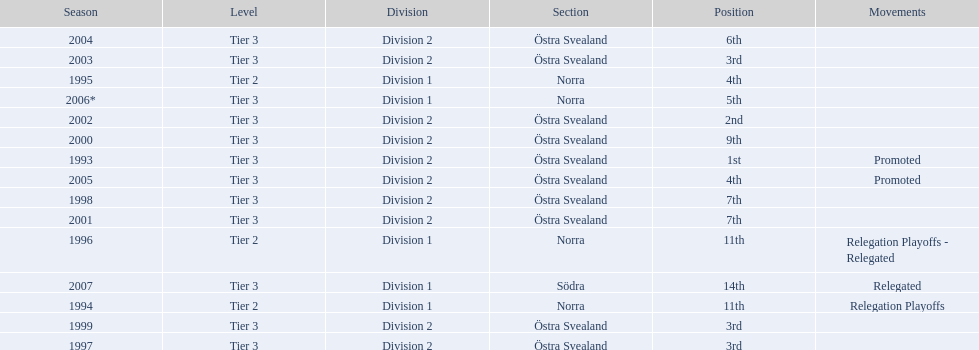Which year was more successful, 2007 or 2002? 2002. 